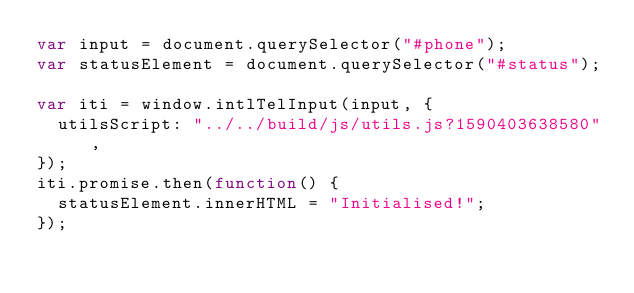Convert code to text. <code><loc_0><loc_0><loc_500><loc_500><_JavaScript_>var input = document.querySelector("#phone");
var statusElement = document.querySelector("#status");

var iti = window.intlTelInput(input, {
  utilsScript: "../../build/js/utils.js?1590403638580",
});
iti.promise.then(function() {
  statusElement.innerHTML = "Initialised!";
});
</code> 